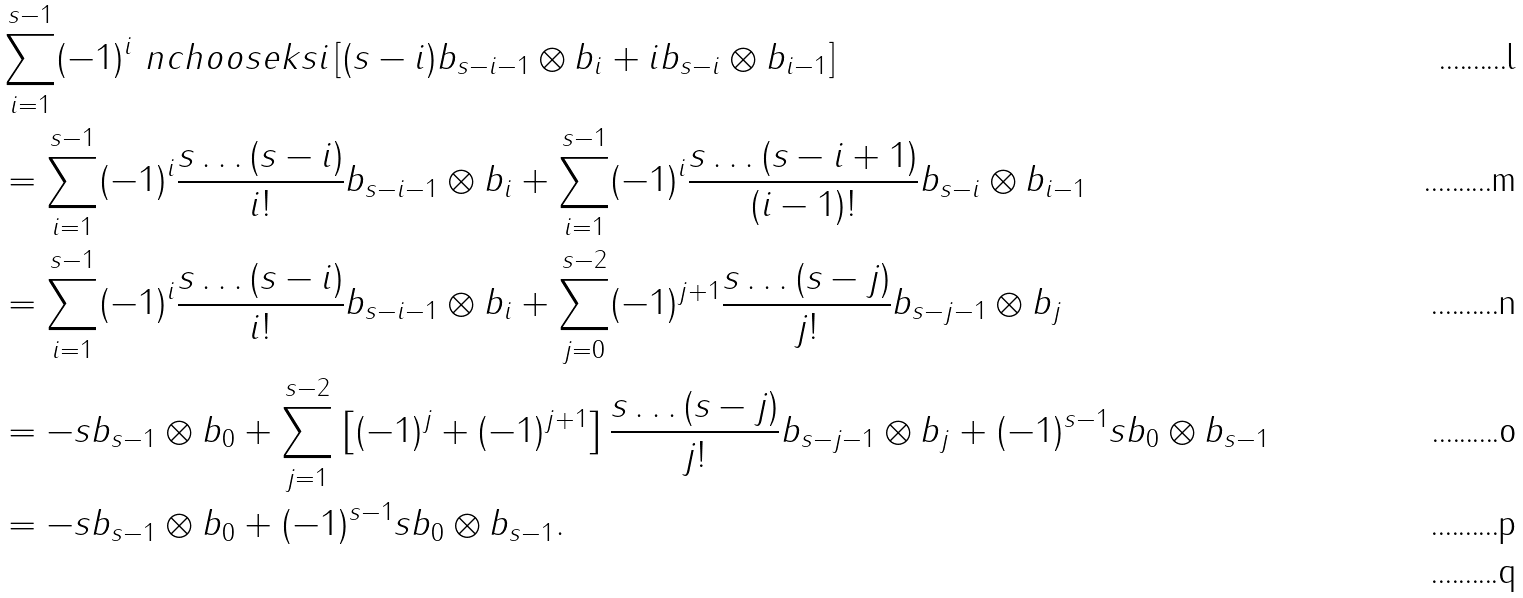<formula> <loc_0><loc_0><loc_500><loc_500>& \sum _ { i = 1 } ^ { s - 1 } ( - 1 ) ^ { i } \ n c h o o s e k { s } { i } \left [ ( s - i ) b _ { s - i - 1 } \otimes b _ { i } + i b _ { s - i } \otimes b _ { i - 1 } \right ] \\ & = \sum _ { i = 1 } ^ { s - 1 } ( - 1 ) ^ { i } \frac { s \dots ( s - i ) } { i ! } b _ { s - i - 1 } \otimes b _ { i } + \sum _ { i = 1 } ^ { s - 1 } ( - 1 ) ^ { i } \frac { s \dots ( s - i + 1 ) } { ( i - 1 ) ! } b _ { s - i } \otimes b _ { i - 1 } \\ & = \sum _ { i = 1 } ^ { s - 1 } ( - 1 ) ^ { i } \frac { s \dots ( s - i ) } { i ! } b _ { s - i - 1 } \otimes b _ { i } + \sum _ { j = 0 } ^ { s - 2 } ( - 1 ) ^ { j + 1 } \frac { s \dots ( s - j ) } { j ! } b _ { s - j - 1 } \otimes b _ { j } \\ & = - s b _ { s - 1 } \otimes b _ { 0 } + \sum _ { j = 1 } ^ { s - 2 } \left [ ( - 1 ) ^ { j } + ( - 1 ) ^ { j + 1 } \right ] \frac { s \dots ( s - j ) } { j ! } b _ { s - j - 1 } \otimes b _ { j } + ( - 1 ) ^ { s - 1 } s b _ { 0 } \otimes b _ { s - 1 } \\ & = - s b _ { s - 1 } \otimes b _ { 0 } + ( - 1 ) ^ { s - 1 } s b _ { 0 } \otimes b _ { s - 1 } . \\</formula> 